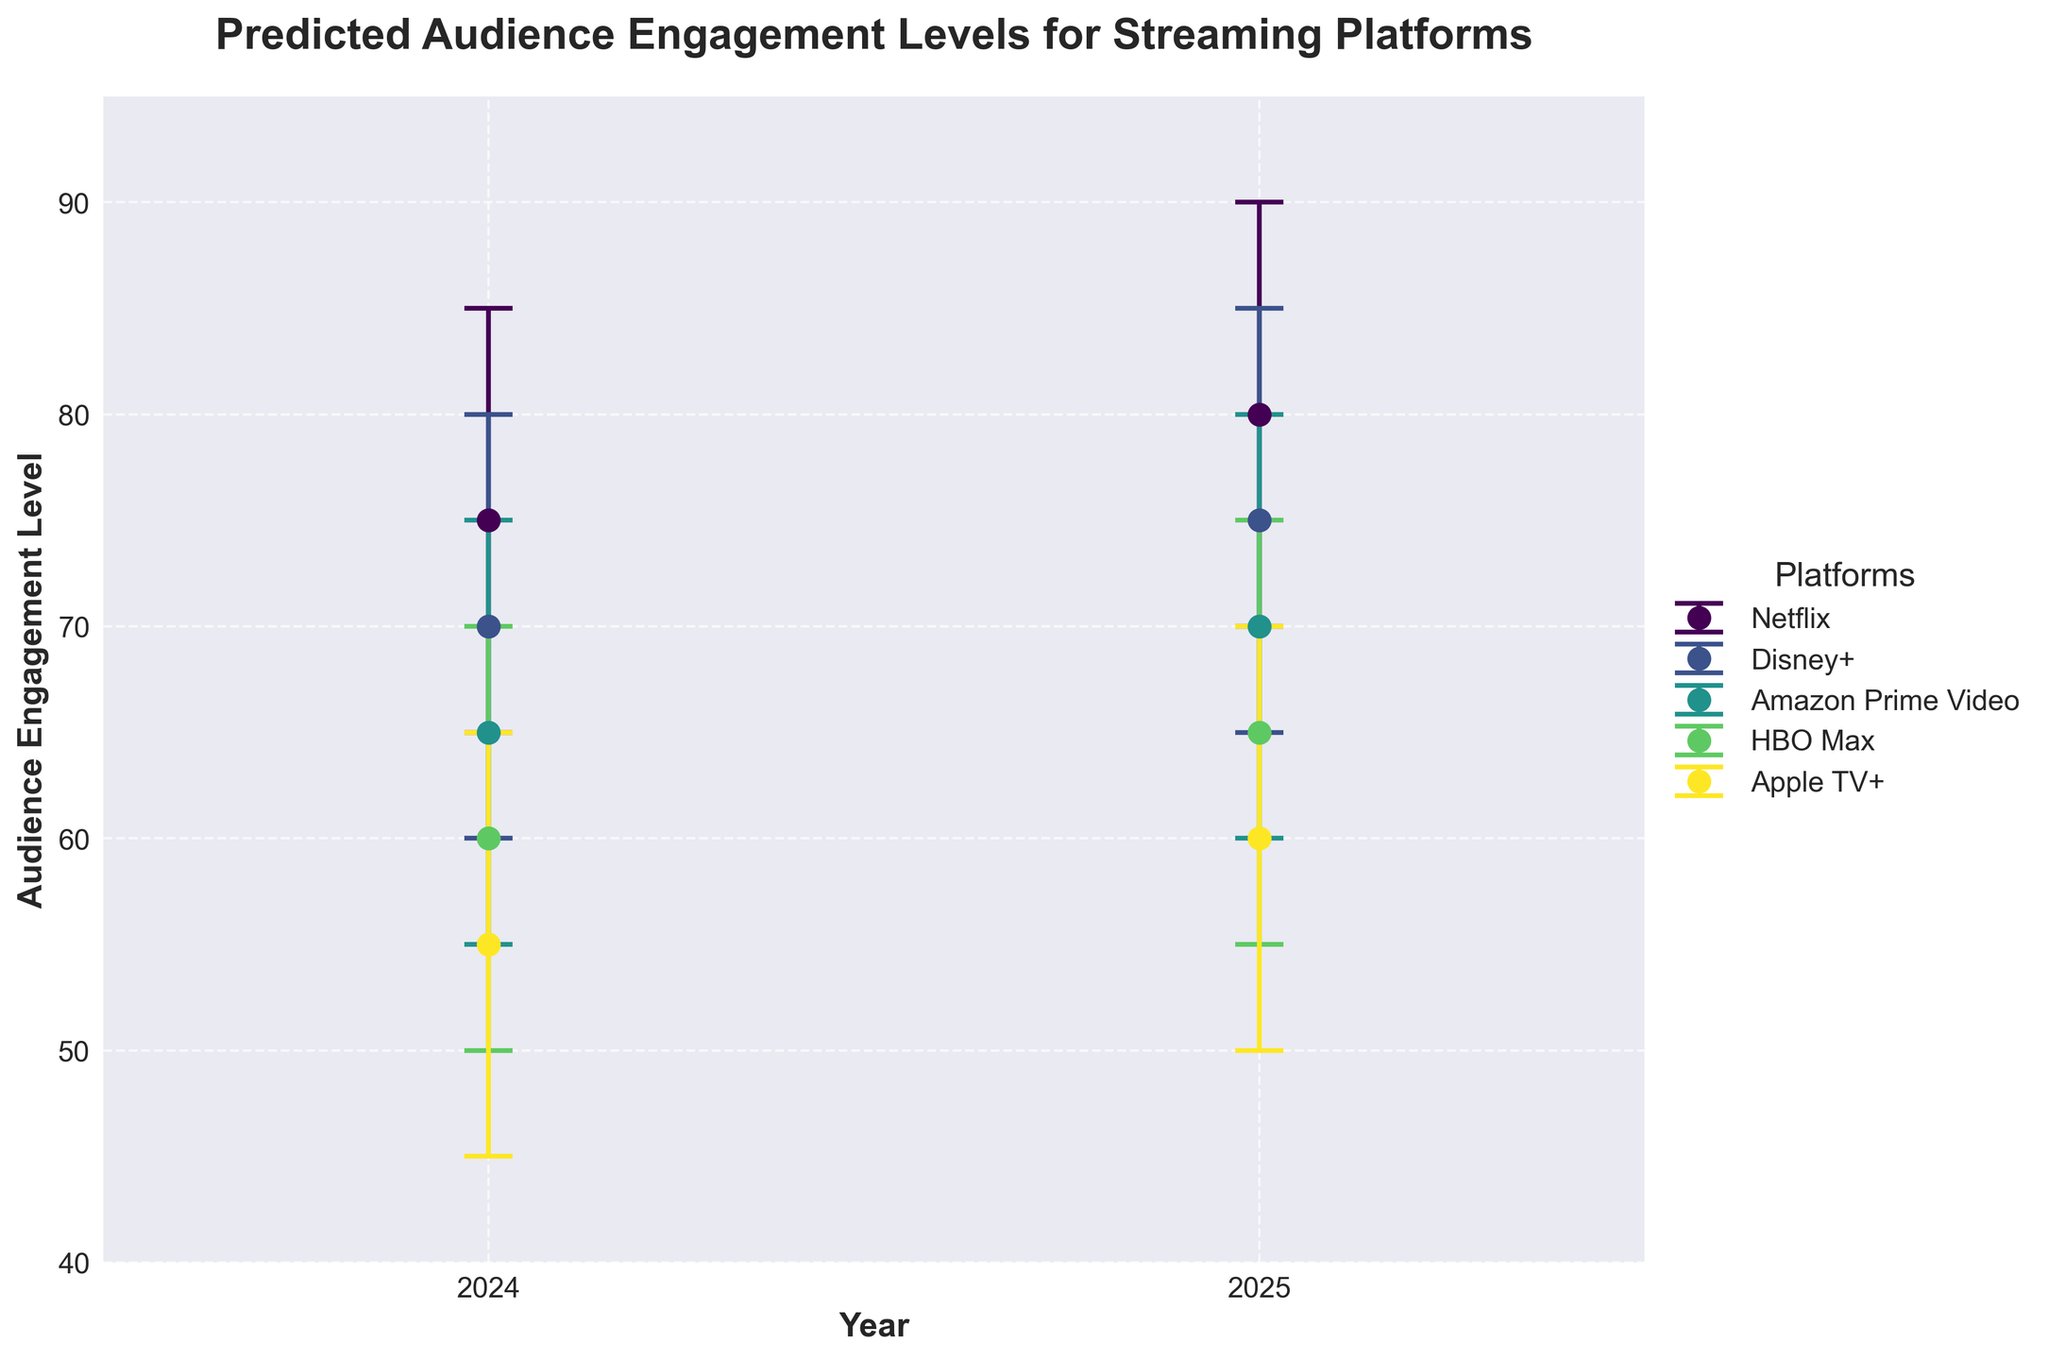What is the predicted audience engagement level for Netflix in 2024? The chart shows multiple engagement levels for each year and platform. For Netflix in 2024, the predicted "Mid" engagement level is indicated.
Answer: 75 Which streaming platform has the lowest predicted "High" engagement level in 2025? The "High" engagement level for each platform in 2025 is listed. Apple TV+ has the lowest "High" engagement level at 70.
Answer: Apple TV+ By how much is the predicted "Mid" engagement level for Amazon Prime Video expected to increase from 2024 to 2025? The "Mid" engagement levels for Amazon Prime Video in 2024 and 2025 are 65 and 70, respectively. The increase is calculated as 70 - 65.
Answer: 5 Which streaming platform shows the greatest predicted increase in its "Low" engagement level from 2024 to 2025? Looking at the "Low" engagement levels for 2024 and 2025, Netflix increases from 65 to 70, Disney+ from 60 to 65, Amazon Prime Video from 55 to 60, HBO Max from 50 to 55, and Apple TV+ from 45 to 50. Each platform shows the same increase of 5.
Answer: All platforms (equally) In 2024, which platform has the smallest difference between its predicted "Low" and "High" engagement levels? For each platform in 2024, calculate the difference between "Low" and "High" engagement levels. Netflix = 85 - 65 = 20, Disney+ = 80 - 60 = 20, Amazon Prime Video = 75 - 55 = 20, HBO Max = 70 - 50 = 20, Apple TV+ = 65 - 45 = 20.
Answer: All platforms (equally) How does the predicted "Mid-High" engagement level for HBO Max in 2024 compare to the "Mid" engagement level for Disney+ in 2025? The "Mid-High" engagement level for HBO Max in 2024 is 65. The "Mid" engagement level for Disney+ in 2025 is 75. Comparing these values, 65 is less than 75.
Answer: Lower Which platform is predicted to have the highest "Mid-High" engagement level in 2025? Look at the "Mid-High" engagement levels for each platform in 2025. Netflix has the highest at 85.
Answer: Netflix Considering 2024 data, how many platforms are expected to have an "Mid" engagement level less than 60? Check the "Mid" engagement levels for each platform in 2024. Apple TV+ has an "Mid" engagement level of 55, which is the only one below 60.
Answer: One (Apple TV+) By how much is the highest predicted "Low-Mid" engagement level for any platform in 2025 greater than the lowest "Low-Mid" engagement level in 2024? The highest "Low-Mid" engagement level in 2025 is 75 (Netflix). The lowest "Low-Mid" engagement level in 2024 is 50 (Apple TV+). The difference is 75 - 50.
Answer: 25 